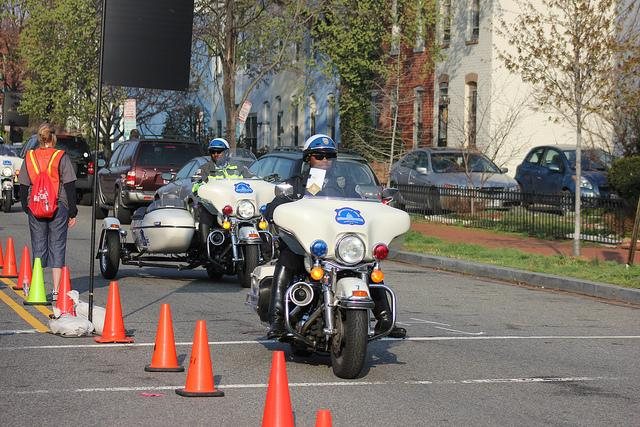What is the use of the following traffic cones? Please explain your reasoning. traffic redirection. The cones block traffic. 